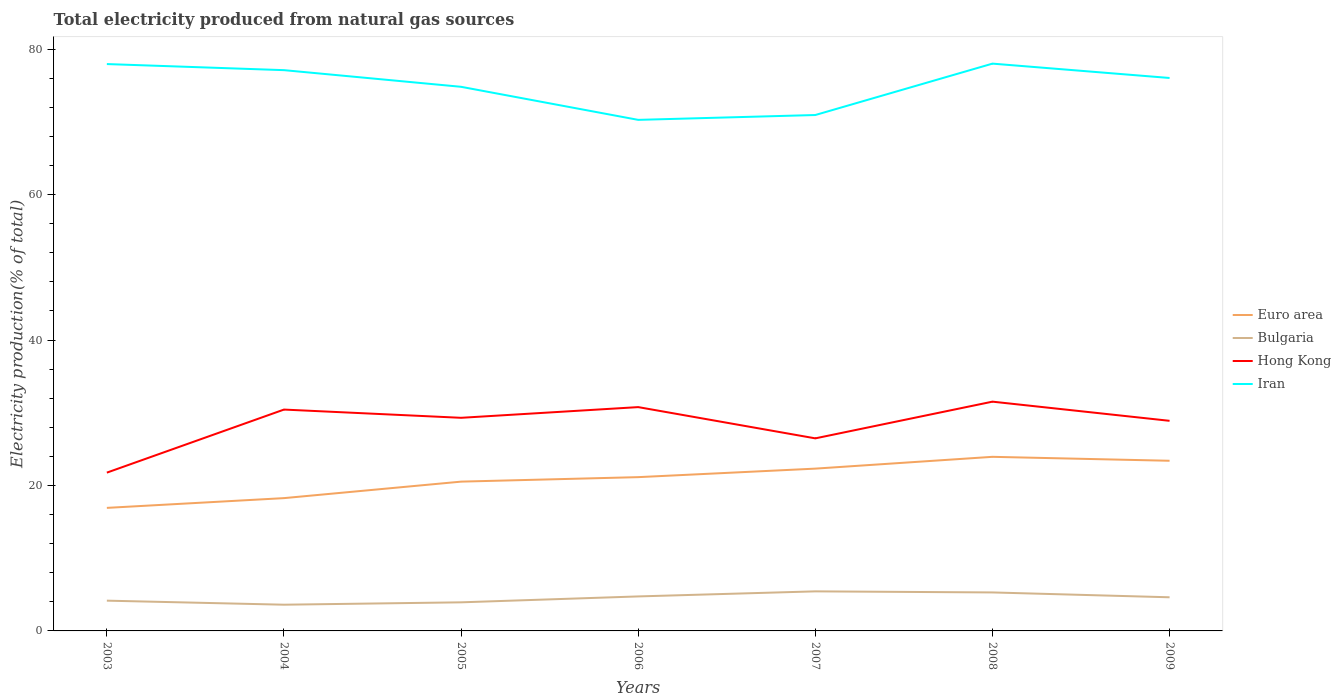Does the line corresponding to Bulgaria intersect with the line corresponding to Euro area?
Provide a succinct answer. No. Across all years, what is the maximum total electricity produced in Hong Kong?
Ensure brevity in your answer.  21.77. In which year was the total electricity produced in Iran maximum?
Your response must be concise. 2006. What is the total total electricity produced in Hong Kong in the graph?
Provide a succinct answer. 2.64. What is the difference between the highest and the second highest total electricity produced in Hong Kong?
Your answer should be very brief. 9.76. Is the total electricity produced in Bulgaria strictly greater than the total electricity produced in Hong Kong over the years?
Give a very brief answer. Yes. How many years are there in the graph?
Offer a terse response. 7. What is the difference between two consecutive major ticks on the Y-axis?
Your answer should be very brief. 20. How many legend labels are there?
Provide a succinct answer. 4. What is the title of the graph?
Your answer should be very brief. Total electricity produced from natural gas sources. What is the label or title of the X-axis?
Ensure brevity in your answer.  Years. What is the label or title of the Y-axis?
Provide a short and direct response. Electricity production(% of total). What is the Electricity production(% of total) of Euro area in 2003?
Provide a succinct answer. 16.92. What is the Electricity production(% of total) in Bulgaria in 2003?
Your answer should be compact. 4.16. What is the Electricity production(% of total) of Hong Kong in 2003?
Your response must be concise. 21.77. What is the Electricity production(% of total) in Iran in 2003?
Provide a short and direct response. 77.96. What is the Electricity production(% of total) of Euro area in 2004?
Offer a terse response. 18.26. What is the Electricity production(% of total) in Bulgaria in 2004?
Your answer should be very brief. 3.61. What is the Electricity production(% of total) of Hong Kong in 2004?
Your response must be concise. 30.44. What is the Electricity production(% of total) in Iran in 2004?
Offer a very short reply. 77.12. What is the Electricity production(% of total) of Euro area in 2005?
Ensure brevity in your answer.  20.53. What is the Electricity production(% of total) in Bulgaria in 2005?
Ensure brevity in your answer.  3.93. What is the Electricity production(% of total) in Hong Kong in 2005?
Your answer should be compact. 29.31. What is the Electricity production(% of total) of Iran in 2005?
Keep it short and to the point. 74.83. What is the Electricity production(% of total) in Euro area in 2006?
Give a very brief answer. 21.15. What is the Electricity production(% of total) of Bulgaria in 2006?
Offer a very short reply. 4.74. What is the Electricity production(% of total) of Hong Kong in 2006?
Ensure brevity in your answer.  30.78. What is the Electricity production(% of total) of Iran in 2006?
Keep it short and to the point. 70.29. What is the Electricity production(% of total) of Euro area in 2007?
Provide a succinct answer. 22.32. What is the Electricity production(% of total) of Bulgaria in 2007?
Your answer should be very brief. 5.44. What is the Electricity production(% of total) of Hong Kong in 2007?
Offer a terse response. 26.48. What is the Electricity production(% of total) in Iran in 2007?
Provide a succinct answer. 70.95. What is the Electricity production(% of total) in Euro area in 2008?
Make the answer very short. 23.94. What is the Electricity production(% of total) of Bulgaria in 2008?
Offer a very short reply. 5.29. What is the Electricity production(% of total) in Hong Kong in 2008?
Give a very brief answer. 31.53. What is the Electricity production(% of total) of Iran in 2008?
Keep it short and to the point. 78.02. What is the Electricity production(% of total) of Euro area in 2009?
Your answer should be very brief. 23.4. What is the Electricity production(% of total) of Bulgaria in 2009?
Make the answer very short. 4.63. What is the Electricity production(% of total) in Hong Kong in 2009?
Make the answer very short. 28.9. What is the Electricity production(% of total) of Iran in 2009?
Your answer should be compact. 76.05. Across all years, what is the maximum Electricity production(% of total) in Euro area?
Keep it short and to the point. 23.94. Across all years, what is the maximum Electricity production(% of total) of Bulgaria?
Give a very brief answer. 5.44. Across all years, what is the maximum Electricity production(% of total) of Hong Kong?
Keep it short and to the point. 31.53. Across all years, what is the maximum Electricity production(% of total) in Iran?
Offer a very short reply. 78.02. Across all years, what is the minimum Electricity production(% of total) of Euro area?
Give a very brief answer. 16.92. Across all years, what is the minimum Electricity production(% of total) of Bulgaria?
Your answer should be compact. 3.61. Across all years, what is the minimum Electricity production(% of total) of Hong Kong?
Your answer should be very brief. 21.77. Across all years, what is the minimum Electricity production(% of total) of Iran?
Offer a very short reply. 70.29. What is the total Electricity production(% of total) in Euro area in the graph?
Your answer should be very brief. 146.53. What is the total Electricity production(% of total) of Bulgaria in the graph?
Give a very brief answer. 31.81. What is the total Electricity production(% of total) in Hong Kong in the graph?
Your answer should be very brief. 199.21. What is the total Electricity production(% of total) in Iran in the graph?
Provide a short and direct response. 525.22. What is the difference between the Electricity production(% of total) of Euro area in 2003 and that in 2004?
Give a very brief answer. -1.34. What is the difference between the Electricity production(% of total) in Bulgaria in 2003 and that in 2004?
Make the answer very short. 0.56. What is the difference between the Electricity production(% of total) in Hong Kong in 2003 and that in 2004?
Your answer should be compact. -8.67. What is the difference between the Electricity production(% of total) of Iran in 2003 and that in 2004?
Offer a very short reply. 0.84. What is the difference between the Electricity production(% of total) in Euro area in 2003 and that in 2005?
Your answer should be very brief. -3.61. What is the difference between the Electricity production(% of total) in Bulgaria in 2003 and that in 2005?
Your answer should be compact. 0.23. What is the difference between the Electricity production(% of total) of Hong Kong in 2003 and that in 2005?
Your answer should be very brief. -7.54. What is the difference between the Electricity production(% of total) in Iran in 2003 and that in 2005?
Provide a short and direct response. 3.13. What is the difference between the Electricity production(% of total) of Euro area in 2003 and that in 2006?
Offer a terse response. -4.23. What is the difference between the Electricity production(% of total) in Bulgaria in 2003 and that in 2006?
Your response must be concise. -0.58. What is the difference between the Electricity production(% of total) in Hong Kong in 2003 and that in 2006?
Your response must be concise. -9.01. What is the difference between the Electricity production(% of total) of Iran in 2003 and that in 2006?
Provide a short and direct response. 7.67. What is the difference between the Electricity production(% of total) of Euro area in 2003 and that in 2007?
Keep it short and to the point. -5.4. What is the difference between the Electricity production(% of total) in Bulgaria in 2003 and that in 2007?
Give a very brief answer. -1.28. What is the difference between the Electricity production(% of total) of Hong Kong in 2003 and that in 2007?
Keep it short and to the point. -4.71. What is the difference between the Electricity production(% of total) in Iran in 2003 and that in 2007?
Make the answer very short. 7.01. What is the difference between the Electricity production(% of total) in Euro area in 2003 and that in 2008?
Give a very brief answer. -7.02. What is the difference between the Electricity production(% of total) in Bulgaria in 2003 and that in 2008?
Offer a very short reply. -1.13. What is the difference between the Electricity production(% of total) of Hong Kong in 2003 and that in 2008?
Make the answer very short. -9.76. What is the difference between the Electricity production(% of total) in Iran in 2003 and that in 2008?
Your answer should be very brief. -0.06. What is the difference between the Electricity production(% of total) in Euro area in 2003 and that in 2009?
Ensure brevity in your answer.  -6.48. What is the difference between the Electricity production(% of total) of Bulgaria in 2003 and that in 2009?
Provide a succinct answer. -0.46. What is the difference between the Electricity production(% of total) of Hong Kong in 2003 and that in 2009?
Offer a terse response. -7.13. What is the difference between the Electricity production(% of total) in Iran in 2003 and that in 2009?
Ensure brevity in your answer.  1.91. What is the difference between the Electricity production(% of total) of Euro area in 2004 and that in 2005?
Keep it short and to the point. -2.27. What is the difference between the Electricity production(% of total) in Bulgaria in 2004 and that in 2005?
Your response must be concise. -0.33. What is the difference between the Electricity production(% of total) of Hong Kong in 2004 and that in 2005?
Provide a short and direct response. 1.13. What is the difference between the Electricity production(% of total) in Iran in 2004 and that in 2005?
Offer a very short reply. 2.29. What is the difference between the Electricity production(% of total) in Euro area in 2004 and that in 2006?
Your answer should be very brief. -2.89. What is the difference between the Electricity production(% of total) of Bulgaria in 2004 and that in 2006?
Offer a terse response. -1.14. What is the difference between the Electricity production(% of total) of Hong Kong in 2004 and that in 2006?
Ensure brevity in your answer.  -0.34. What is the difference between the Electricity production(% of total) in Iran in 2004 and that in 2006?
Offer a very short reply. 6.84. What is the difference between the Electricity production(% of total) of Euro area in 2004 and that in 2007?
Make the answer very short. -4.06. What is the difference between the Electricity production(% of total) of Bulgaria in 2004 and that in 2007?
Ensure brevity in your answer.  -1.83. What is the difference between the Electricity production(% of total) of Hong Kong in 2004 and that in 2007?
Keep it short and to the point. 3.96. What is the difference between the Electricity production(% of total) in Iran in 2004 and that in 2007?
Offer a terse response. 6.17. What is the difference between the Electricity production(% of total) in Euro area in 2004 and that in 2008?
Keep it short and to the point. -5.68. What is the difference between the Electricity production(% of total) in Bulgaria in 2004 and that in 2008?
Keep it short and to the point. -1.69. What is the difference between the Electricity production(% of total) of Hong Kong in 2004 and that in 2008?
Provide a short and direct response. -1.09. What is the difference between the Electricity production(% of total) in Iran in 2004 and that in 2008?
Your answer should be compact. -0.9. What is the difference between the Electricity production(% of total) of Euro area in 2004 and that in 2009?
Offer a terse response. -5.14. What is the difference between the Electricity production(% of total) of Bulgaria in 2004 and that in 2009?
Your answer should be compact. -1.02. What is the difference between the Electricity production(% of total) of Hong Kong in 2004 and that in 2009?
Make the answer very short. 1.55. What is the difference between the Electricity production(% of total) in Iran in 2004 and that in 2009?
Make the answer very short. 1.08. What is the difference between the Electricity production(% of total) of Euro area in 2005 and that in 2006?
Your answer should be very brief. -0.62. What is the difference between the Electricity production(% of total) in Bulgaria in 2005 and that in 2006?
Keep it short and to the point. -0.81. What is the difference between the Electricity production(% of total) in Hong Kong in 2005 and that in 2006?
Offer a terse response. -1.47. What is the difference between the Electricity production(% of total) in Iran in 2005 and that in 2006?
Offer a terse response. 4.55. What is the difference between the Electricity production(% of total) of Euro area in 2005 and that in 2007?
Provide a short and direct response. -1.79. What is the difference between the Electricity production(% of total) of Bulgaria in 2005 and that in 2007?
Provide a short and direct response. -1.51. What is the difference between the Electricity production(% of total) in Hong Kong in 2005 and that in 2007?
Ensure brevity in your answer.  2.83. What is the difference between the Electricity production(% of total) of Iran in 2005 and that in 2007?
Keep it short and to the point. 3.88. What is the difference between the Electricity production(% of total) of Euro area in 2005 and that in 2008?
Keep it short and to the point. -3.41. What is the difference between the Electricity production(% of total) in Bulgaria in 2005 and that in 2008?
Give a very brief answer. -1.36. What is the difference between the Electricity production(% of total) in Hong Kong in 2005 and that in 2008?
Ensure brevity in your answer.  -2.22. What is the difference between the Electricity production(% of total) of Iran in 2005 and that in 2008?
Your answer should be very brief. -3.19. What is the difference between the Electricity production(% of total) in Euro area in 2005 and that in 2009?
Make the answer very short. -2.87. What is the difference between the Electricity production(% of total) in Bulgaria in 2005 and that in 2009?
Ensure brevity in your answer.  -0.69. What is the difference between the Electricity production(% of total) of Hong Kong in 2005 and that in 2009?
Make the answer very short. 0.41. What is the difference between the Electricity production(% of total) in Iran in 2005 and that in 2009?
Offer a terse response. -1.21. What is the difference between the Electricity production(% of total) in Euro area in 2006 and that in 2007?
Offer a terse response. -1.17. What is the difference between the Electricity production(% of total) in Bulgaria in 2006 and that in 2007?
Ensure brevity in your answer.  -0.7. What is the difference between the Electricity production(% of total) in Hong Kong in 2006 and that in 2007?
Ensure brevity in your answer.  4.3. What is the difference between the Electricity production(% of total) of Iran in 2006 and that in 2007?
Give a very brief answer. -0.67. What is the difference between the Electricity production(% of total) of Euro area in 2006 and that in 2008?
Keep it short and to the point. -2.79. What is the difference between the Electricity production(% of total) in Bulgaria in 2006 and that in 2008?
Keep it short and to the point. -0.55. What is the difference between the Electricity production(% of total) of Hong Kong in 2006 and that in 2008?
Your answer should be compact. -0.75. What is the difference between the Electricity production(% of total) of Iran in 2006 and that in 2008?
Your answer should be very brief. -7.73. What is the difference between the Electricity production(% of total) of Euro area in 2006 and that in 2009?
Your response must be concise. -2.25. What is the difference between the Electricity production(% of total) of Bulgaria in 2006 and that in 2009?
Offer a terse response. 0.12. What is the difference between the Electricity production(% of total) of Hong Kong in 2006 and that in 2009?
Your answer should be compact. 1.89. What is the difference between the Electricity production(% of total) of Iran in 2006 and that in 2009?
Provide a short and direct response. -5.76. What is the difference between the Electricity production(% of total) in Euro area in 2007 and that in 2008?
Give a very brief answer. -1.62. What is the difference between the Electricity production(% of total) of Bulgaria in 2007 and that in 2008?
Offer a very short reply. 0.15. What is the difference between the Electricity production(% of total) in Hong Kong in 2007 and that in 2008?
Keep it short and to the point. -5.05. What is the difference between the Electricity production(% of total) in Iran in 2007 and that in 2008?
Give a very brief answer. -7.07. What is the difference between the Electricity production(% of total) in Euro area in 2007 and that in 2009?
Offer a terse response. -1.08. What is the difference between the Electricity production(% of total) of Bulgaria in 2007 and that in 2009?
Provide a short and direct response. 0.81. What is the difference between the Electricity production(% of total) of Hong Kong in 2007 and that in 2009?
Your answer should be compact. -2.41. What is the difference between the Electricity production(% of total) of Iran in 2007 and that in 2009?
Your answer should be very brief. -5.09. What is the difference between the Electricity production(% of total) of Euro area in 2008 and that in 2009?
Your answer should be compact. 0.54. What is the difference between the Electricity production(% of total) of Bulgaria in 2008 and that in 2009?
Your answer should be compact. 0.67. What is the difference between the Electricity production(% of total) in Hong Kong in 2008 and that in 2009?
Keep it short and to the point. 2.64. What is the difference between the Electricity production(% of total) in Iran in 2008 and that in 2009?
Your answer should be compact. 1.97. What is the difference between the Electricity production(% of total) of Euro area in 2003 and the Electricity production(% of total) of Bulgaria in 2004?
Your answer should be very brief. 13.32. What is the difference between the Electricity production(% of total) in Euro area in 2003 and the Electricity production(% of total) in Hong Kong in 2004?
Keep it short and to the point. -13.52. What is the difference between the Electricity production(% of total) of Euro area in 2003 and the Electricity production(% of total) of Iran in 2004?
Ensure brevity in your answer.  -60.2. What is the difference between the Electricity production(% of total) of Bulgaria in 2003 and the Electricity production(% of total) of Hong Kong in 2004?
Keep it short and to the point. -26.28. What is the difference between the Electricity production(% of total) of Bulgaria in 2003 and the Electricity production(% of total) of Iran in 2004?
Ensure brevity in your answer.  -72.96. What is the difference between the Electricity production(% of total) in Hong Kong in 2003 and the Electricity production(% of total) in Iran in 2004?
Your response must be concise. -55.35. What is the difference between the Electricity production(% of total) of Euro area in 2003 and the Electricity production(% of total) of Bulgaria in 2005?
Offer a terse response. 12.99. What is the difference between the Electricity production(% of total) of Euro area in 2003 and the Electricity production(% of total) of Hong Kong in 2005?
Offer a very short reply. -12.39. What is the difference between the Electricity production(% of total) of Euro area in 2003 and the Electricity production(% of total) of Iran in 2005?
Give a very brief answer. -57.91. What is the difference between the Electricity production(% of total) of Bulgaria in 2003 and the Electricity production(% of total) of Hong Kong in 2005?
Ensure brevity in your answer.  -25.15. What is the difference between the Electricity production(% of total) of Bulgaria in 2003 and the Electricity production(% of total) of Iran in 2005?
Your response must be concise. -70.67. What is the difference between the Electricity production(% of total) of Hong Kong in 2003 and the Electricity production(% of total) of Iran in 2005?
Provide a short and direct response. -53.06. What is the difference between the Electricity production(% of total) of Euro area in 2003 and the Electricity production(% of total) of Bulgaria in 2006?
Ensure brevity in your answer.  12.18. What is the difference between the Electricity production(% of total) of Euro area in 2003 and the Electricity production(% of total) of Hong Kong in 2006?
Provide a succinct answer. -13.86. What is the difference between the Electricity production(% of total) in Euro area in 2003 and the Electricity production(% of total) in Iran in 2006?
Your answer should be compact. -53.36. What is the difference between the Electricity production(% of total) of Bulgaria in 2003 and the Electricity production(% of total) of Hong Kong in 2006?
Give a very brief answer. -26.62. What is the difference between the Electricity production(% of total) in Bulgaria in 2003 and the Electricity production(% of total) in Iran in 2006?
Provide a short and direct response. -66.12. What is the difference between the Electricity production(% of total) in Hong Kong in 2003 and the Electricity production(% of total) in Iran in 2006?
Make the answer very short. -48.52. What is the difference between the Electricity production(% of total) in Euro area in 2003 and the Electricity production(% of total) in Bulgaria in 2007?
Your answer should be very brief. 11.48. What is the difference between the Electricity production(% of total) in Euro area in 2003 and the Electricity production(% of total) in Hong Kong in 2007?
Your response must be concise. -9.56. What is the difference between the Electricity production(% of total) of Euro area in 2003 and the Electricity production(% of total) of Iran in 2007?
Ensure brevity in your answer.  -54.03. What is the difference between the Electricity production(% of total) in Bulgaria in 2003 and the Electricity production(% of total) in Hong Kong in 2007?
Offer a terse response. -22.32. What is the difference between the Electricity production(% of total) in Bulgaria in 2003 and the Electricity production(% of total) in Iran in 2007?
Make the answer very short. -66.79. What is the difference between the Electricity production(% of total) in Hong Kong in 2003 and the Electricity production(% of total) in Iran in 2007?
Make the answer very short. -49.18. What is the difference between the Electricity production(% of total) of Euro area in 2003 and the Electricity production(% of total) of Bulgaria in 2008?
Provide a succinct answer. 11.63. What is the difference between the Electricity production(% of total) of Euro area in 2003 and the Electricity production(% of total) of Hong Kong in 2008?
Provide a short and direct response. -14.61. What is the difference between the Electricity production(% of total) of Euro area in 2003 and the Electricity production(% of total) of Iran in 2008?
Provide a succinct answer. -61.1. What is the difference between the Electricity production(% of total) in Bulgaria in 2003 and the Electricity production(% of total) in Hong Kong in 2008?
Offer a very short reply. -27.37. What is the difference between the Electricity production(% of total) of Bulgaria in 2003 and the Electricity production(% of total) of Iran in 2008?
Give a very brief answer. -73.86. What is the difference between the Electricity production(% of total) of Hong Kong in 2003 and the Electricity production(% of total) of Iran in 2008?
Keep it short and to the point. -56.25. What is the difference between the Electricity production(% of total) in Euro area in 2003 and the Electricity production(% of total) in Bulgaria in 2009?
Your answer should be compact. 12.3. What is the difference between the Electricity production(% of total) of Euro area in 2003 and the Electricity production(% of total) of Hong Kong in 2009?
Provide a succinct answer. -11.97. What is the difference between the Electricity production(% of total) in Euro area in 2003 and the Electricity production(% of total) in Iran in 2009?
Offer a terse response. -59.12. What is the difference between the Electricity production(% of total) in Bulgaria in 2003 and the Electricity production(% of total) in Hong Kong in 2009?
Give a very brief answer. -24.73. What is the difference between the Electricity production(% of total) in Bulgaria in 2003 and the Electricity production(% of total) in Iran in 2009?
Make the answer very short. -71.88. What is the difference between the Electricity production(% of total) of Hong Kong in 2003 and the Electricity production(% of total) of Iran in 2009?
Offer a terse response. -54.28. What is the difference between the Electricity production(% of total) of Euro area in 2004 and the Electricity production(% of total) of Bulgaria in 2005?
Give a very brief answer. 14.33. What is the difference between the Electricity production(% of total) in Euro area in 2004 and the Electricity production(% of total) in Hong Kong in 2005?
Your answer should be very brief. -11.05. What is the difference between the Electricity production(% of total) of Euro area in 2004 and the Electricity production(% of total) of Iran in 2005?
Your response must be concise. -56.57. What is the difference between the Electricity production(% of total) in Bulgaria in 2004 and the Electricity production(% of total) in Hong Kong in 2005?
Your answer should be compact. -25.7. What is the difference between the Electricity production(% of total) of Bulgaria in 2004 and the Electricity production(% of total) of Iran in 2005?
Give a very brief answer. -71.23. What is the difference between the Electricity production(% of total) of Hong Kong in 2004 and the Electricity production(% of total) of Iran in 2005?
Provide a succinct answer. -44.39. What is the difference between the Electricity production(% of total) of Euro area in 2004 and the Electricity production(% of total) of Bulgaria in 2006?
Provide a short and direct response. 13.52. What is the difference between the Electricity production(% of total) in Euro area in 2004 and the Electricity production(% of total) in Hong Kong in 2006?
Your answer should be compact. -12.52. What is the difference between the Electricity production(% of total) in Euro area in 2004 and the Electricity production(% of total) in Iran in 2006?
Give a very brief answer. -52.02. What is the difference between the Electricity production(% of total) in Bulgaria in 2004 and the Electricity production(% of total) in Hong Kong in 2006?
Your answer should be very brief. -27.18. What is the difference between the Electricity production(% of total) of Bulgaria in 2004 and the Electricity production(% of total) of Iran in 2006?
Your answer should be compact. -66.68. What is the difference between the Electricity production(% of total) of Hong Kong in 2004 and the Electricity production(% of total) of Iran in 2006?
Provide a short and direct response. -39.84. What is the difference between the Electricity production(% of total) in Euro area in 2004 and the Electricity production(% of total) in Bulgaria in 2007?
Offer a very short reply. 12.82. What is the difference between the Electricity production(% of total) in Euro area in 2004 and the Electricity production(% of total) in Hong Kong in 2007?
Offer a terse response. -8.22. What is the difference between the Electricity production(% of total) of Euro area in 2004 and the Electricity production(% of total) of Iran in 2007?
Your response must be concise. -52.69. What is the difference between the Electricity production(% of total) in Bulgaria in 2004 and the Electricity production(% of total) in Hong Kong in 2007?
Offer a very short reply. -22.88. What is the difference between the Electricity production(% of total) of Bulgaria in 2004 and the Electricity production(% of total) of Iran in 2007?
Offer a terse response. -67.35. What is the difference between the Electricity production(% of total) of Hong Kong in 2004 and the Electricity production(% of total) of Iran in 2007?
Keep it short and to the point. -40.51. What is the difference between the Electricity production(% of total) in Euro area in 2004 and the Electricity production(% of total) in Bulgaria in 2008?
Provide a short and direct response. 12.97. What is the difference between the Electricity production(% of total) of Euro area in 2004 and the Electricity production(% of total) of Hong Kong in 2008?
Ensure brevity in your answer.  -13.27. What is the difference between the Electricity production(% of total) in Euro area in 2004 and the Electricity production(% of total) in Iran in 2008?
Provide a succinct answer. -59.76. What is the difference between the Electricity production(% of total) of Bulgaria in 2004 and the Electricity production(% of total) of Hong Kong in 2008?
Offer a terse response. -27.92. What is the difference between the Electricity production(% of total) of Bulgaria in 2004 and the Electricity production(% of total) of Iran in 2008?
Offer a very short reply. -74.41. What is the difference between the Electricity production(% of total) of Hong Kong in 2004 and the Electricity production(% of total) of Iran in 2008?
Offer a very short reply. -47.58. What is the difference between the Electricity production(% of total) in Euro area in 2004 and the Electricity production(% of total) in Bulgaria in 2009?
Provide a short and direct response. 13.64. What is the difference between the Electricity production(% of total) in Euro area in 2004 and the Electricity production(% of total) in Hong Kong in 2009?
Offer a very short reply. -10.63. What is the difference between the Electricity production(% of total) of Euro area in 2004 and the Electricity production(% of total) of Iran in 2009?
Your answer should be compact. -57.78. What is the difference between the Electricity production(% of total) in Bulgaria in 2004 and the Electricity production(% of total) in Hong Kong in 2009?
Ensure brevity in your answer.  -25.29. What is the difference between the Electricity production(% of total) of Bulgaria in 2004 and the Electricity production(% of total) of Iran in 2009?
Your answer should be compact. -72.44. What is the difference between the Electricity production(% of total) of Hong Kong in 2004 and the Electricity production(% of total) of Iran in 2009?
Ensure brevity in your answer.  -45.6. What is the difference between the Electricity production(% of total) in Euro area in 2005 and the Electricity production(% of total) in Bulgaria in 2006?
Give a very brief answer. 15.79. What is the difference between the Electricity production(% of total) in Euro area in 2005 and the Electricity production(% of total) in Hong Kong in 2006?
Your response must be concise. -10.25. What is the difference between the Electricity production(% of total) in Euro area in 2005 and the Electricity production(% of total) in Iran in 2006?
Your answer should be very brief. -49.75. What is the difference between the Electricity production(% of total) in Bulgaria in 2005 and the Electricity production(% of total) in Hong Kong in 2006?
Offer a terse response. -26.85. What is the difference between the Electricity production(% of total) in Bulgaria in 2005 and the Electricity production(% of total) in Iran in 2006?
Provide a succinct answer. -66.35. What is the difference between the Electricity production(% of total) in Hong Kong in 2005 and the Electricity production(% of total) in Iran in 2006?
Your answer should be very brief. -40.98. What is the difference between the Electricity production(% of total) of Euro area in 2005 and the Electricity production(% of total) of Bulgaria in 2007?
Provide a short and direct response. 15.09. What is the difference between the Electricity production(% of total) of Euro area in 2005 and the Electricity production(% of total) of Hong Kong in 2007?
Provide a succinct answer. -5.95. What is the difference between the Electricity production(% of total) in Euro area in 2005 and the Electricity production(% of total) in Iran in 2007?
Keep it short and to the point. -50.42. What is the difference between the Electricity production(% of total) in Bulgaria in 2005 and the Electricity production(% of total) in Hong Kong in 2007?
Offer a terse response. -22.55. What is the difference between the Electricity production(% of total) of Bulgaria in 2005 and the Electricity production(% of total) of Iran in 2007?
Ensure brevity in your answer.  -67.02. What is the difference between the Electricity production(% of total) in Hong Kong in 2005 and the Electricity production(% of total) in Iran in 2007?
Make the answer very short. -41.64. What is the difference between the Electricity production(% of total) in Euro area in 2005 and the Electricity production(% of total) in Bulgaria in 2008?
Provide a short and direct response. 15.24. What is the difference between the Electricity production(% of total) in Euro area in 2005 and the Electricity production(% of total) in Hong Kong in 2008?
Provide a short and direct response. -11. What is the difference between the Electricity production(% of total) in Euro area in 2005 and the Electricity production(% of total) in Iran in 2008?
Make the answer very short. -57.49. What is the difference between the Electricity production(% of total) in Bulgaria in 2005 and the Electricity production(% of total) in Hong Kong in 2008?
Provide a succinct answer. -27.6. What is the difference between the Electricity production(% of total) in Bulgaria in 2005 and the Electricity production(% of total) in Iran in 2008?
Your answer should be very brief. -74.09. What is the difference between the Electricity production(% of total) of Hong Kong in 2005 and the Electricity production(% of total) of Iran in 2008?
Provide a short and direct response. -48.71. What is the difference between the Electricity production(% of total) in Euro area in 2005 and the Electricity production(% of total) in Bulgaria in 2009?
Offer a very short reply. 15.91. What is the difference between the Electricity production(% of total) in Euro area in 2005 and the Electricity production(% of total) in Hong Kong in 2009?
Your answer should be very brief. -8.36. What is the difference between the Electricity production(% of total) in Euro area in 2005 and the Electricity production(% of total) in Iran in 2009?
Provide a succinct answer. -55.51. What is the difference between the Electricity production(% of total) of Bulgaria in 2005 and the Electricity production(% of total) of Hong Kong in 2009?
Your response must be concise. -24.96. What is the difference between the Electricity production(% of total) in Bulgaria in 2005 and the Electricity production(% of total) in Iran in 2009?
Provide a short and direct response. -72.11. What is the difference between the Electricity production(% of total) of Hong Kong in 2005 and the Electricity production(% of total) of Iran in 2009?
Offer a very short reply. -46.74. What is the difference between the Electricity production(% of total) in Euro area in 2006 and the Electricity production(% of total) in Bulgaria in 2007?
Your answer should be very brief. 15.71. What is the difference between the Electricity production(% of total) of Euro area in 2006 and the Electricity production(% of total) of Hong Kong in 2007?
Keep it short and to the point. -5.33. What is the difference between the Electricity production(% of total) of Euro area in 2006 and the Electricity production(% of total) of Iran in 2007?
Your answer should be compact. -49.8. What is the difference between the Electricity production(% of total) in Bulgaria in 2006 and the Electricity production(% of total) in Hong Kong in 2007?
Provide a succinct answer. -21.74. What is the difference between the Electricity production(% of total) of Bulgaria in 2006 and the Electricity production(% of total) of Iran in 2007?
Provide a short and direct response. -66.21. What is the difference between the Electricity production(% of total) of Hong Kong in 2006 and the Electricity production(% of total) of Iran in 2007?
Make the answer very short. -40.17. What is the difference between the Electricity production(% of total) in Euro area in 2006 and the Electricity production(% of total) in Bulgaria in 2008?
Give a very brief answer. 15.86. What is the difference between the Electricity production(% of total) in Euro area in 2006 and the Electricity production(% of total) in Hong Kong in 2008?
Provide a short and direct response. -10.38. What is the difference between the Electricity production(% of total) in Euro area in 2006 and the Electricity production(% of total) in Iran in 2008?
Keep it short and to the point. -56.87. What is the difference between the Electricity production(% of total) of Bulgaria in 2006 and the Electricity production(% of total) of Hong Kong in 2008?
Your answer should be compact. -26.79. What is the difference between the Electricity production(% of total) in Bulgaria in 2006 and the Electricity production(% of total) in Iran in 2008?
Give a very brief answer. -73.28. What is the difference between the Electricity production(% of total) of Hong Kong in 2006 and the Electricity production(% of total) of Iran in 2008?
Your answer should be compact. -47.24. What is the difference between the Electricity production(% of total) in Euro area in 2006 and the Electricity production(% of total) in Bulgaria in 2009?
Keep it short and to the point. 16.52. What is the difference between the Electricity production(% of total) in Euro area in 2006 and the Electricity production(% of total) in Hong Kong in 2009?
Give a very brief answer. -7.75. What is the difference between the Electricity production(% of total) of Euro area in 2006 and the Electricity production(% of total) of Iran in 2009?
Keep it short and to the point. -54.9. What is the difference between the Electricity production(% of total) of Bulgaria in 2006 and the Electricity production(% of total) of Hong Kong in 2009?
Ensure brevity in your answer.  -24.15. What is the difference between the Electricity production(% of total) in Bulgaria in 2006 and the Electricity production(% of total) in Iran in 2009?
Your answer should be very brief. -71.3. What is the difference between the Electricity production(% of total) in Hong Kong in 2006 and the Electricity production(% of total) in Iran in 2009?
Ensure brevity in your answer.  -45.26. What is the difference between the Electricity production(% of total) of Euro area in 2007 and the Electricity production(% of total) of Bulgaria in 2008?
Give a very brief answer. 17.03. What is the difference between the Electricity production(% of total) in Euro area in 2007 and the Electricity production(% of total) in Hong Kong in 2008?
Offer a terse response. -9.21. What is the difference between the Electricity production(% of total) of Euro area in 2007 and the Electricity production(% of total) of Iran in 2008?
Keep it short and to the point. -55.7. What is the difference between the Electricity production(% of total) of Bulgaria in 2007 and the Electricity production(% of total) of Hong Kong in 2008?
Give a very brief answer. -26.09. What is the difference between the Electricity production(% of total) in Bulgaria in 2007 and the Electricity production(% of total) in Iran in 2008?
Make the answer very short. -72.58. What is the difference between the Electricity production(% of total) in Hong Kong in 2007 and the Electricity production(% of total) in Iran in 2008?
Provide a succinct answer. -51.54. What is the difference between the Electricity production(% of total) in Euro area in 2007 and the Electricity production(% of total) in Bulgaria in 2009?
Your answer should be compact. 17.69. What is the difference between the Electricity production(% of total) in Euro area in 2007 and the Electricity production(% of total) in Hong Kong in 2009?
Ensure brevity in your answer.  -6.58. What is the difference between the Electricity production(% of total) of Euro area in 2007 and the Electricity production(% of total) of Iran in 2009?
Your answer should be compact. -53.73. What is the difference between the Electricity production(% of total) of Bulgaria in 2007 and the Electricity production(% of total) of Hong Kong in 2009?
Ensure brevity in your answer.  -23.46. What is the difference between the Electricity production(% of total) in Bulgaria in 2007 and the Electricity production(% of total) in Iran in 2009?
Ensure brevity in your answer.  -70.61. What is the difference between the Electricity production(% of total) of Hong Kong in 2007 and the Electricity production(% of total) of Iran in 2009?
Your response must be concise. -49.56. What is the difference between the Electricity production(% of total) in Euro area in 2008 and the Electricity production(% of total) in Bulgaria in 2009?
Your answer should be very brief. 19.32. What is the difference between the Electricity production(% of total) in Euro area in 2008 and the Electricity production(% of total) in Hong Kong in 2009?
Ensure brevity in your answer.  -4.95. What is the difference between the Electricity production(% of total) of Euro area in 2008 and the Electricity production(% of total) of Iran in 2009?
Keep it short and to the point. -52.1. What is the difference between the Electricity production(% of total) of Bulgaria in 2008 and the Electricity production(% of total) of Hong Kong in 2009?
Offer a very short reply. -23.6. What is the difference between the Electricity production(% of total) in Bulgaria in 2008 and the Electricity production(% of total) in Iran in 2009?
Give a very brief answer. -70.75. What is the difference between the Electricity production(% of total) of Hong Kong in 2008 and the Electricity production(% of total) of Iran in 2009?
Your response must be concise. -44.51. What is the average Electricity production(% of total) in Euro area per year?
Your response must be concise. 20.93. What is the average Electricity production(% of total) in Bulgaria per year?
Provide a succinct answer. 4.54. What is the average Electricity production(% of total) of Hong Kong per year?
Your answer should be compact. 28.46. What is the average Electricity production(% of total) in Iran per year?
Your answer should be very brief. 75.03. In the year 2003, what is the difference between the Electricity production(% of total) of Euro area and Electricity production(% of total) of Bulgaria?
Ensure brevity in your answer.  12.76. In the year 2003, what is the difference between the Electricity production(% of total) of Euro area and Electricity production(% of total) of Hong Kong?
Keep it short and to the point. -4.85. In the year 2003, what is the difference between the Electricity production(% of total) in Euro area and Electricity production(% of total) in Iran?
Give a very brief answer. -61.04. In the year 2003, what is the difference between the Electricity production(% of total) of Bulgaria and Electricity production(% of total) of Hong Kong?
Make the answer very short. -17.61. In the year 2003, what is the difference between the Electricity production(% of total) of Bulgaria and Electricity production(% of total) of Iran?
Make the answer very short. -73.8. In the year 2003, what is the difference between the Electricity production(% of total) of Hong Kong and Electricity production(% of total) of Iran?
Your answer should be compact. -56.19. In the year 2004, what is the difference between the Electricity production(% of total) in Euro area and Electricity production(% of total) in Bulgaria?
Your answer should be compact. 14.66. In the year 2004, what is the difference between the Electricity production(% of total) in Euro area and Electricity production(% of total) in Hong Kong?
Give a very brief answer. -12.18. In the year 2004, what is the difference between the Electricity production(% of total) in Euro area and Electricity production(% of total) in Iran?
Offer a very short reply. -58.86. In the year 2004, what is the difference between the Electricity production(% of total) in Bulgaria and Electricity production(% of total) in Hong Kong?
Offer a very short reply. -26.84. In the year 2004, what is the difference between the Electricity production(% of total) of Bulgaria and Electricity production(% of total) of Iran?
Your answer should be compact. -73.52. In the year 2004, what is the difference between the Electricity production(% of total) in Hong Kong and Electricity production(% of total) in Iran?
Your answer should be very brief. -46.68. In the year 2005, what is the difference between the Electricity production(% of total) in Euro area and Electricity production(% of total) in Bulgaria?
Offer a terse response. 16.6. In the year 2005, what is the difference between the Electricity production(% of total) in Euro area and Electricity production(% of total) in Hong Kong?
Your answer should be compact. -8.78. In the year 2005, what is the difference between the Electricity production(% of total) of Euro area and Electricity production(% of total) of Iran?
Offer a very short reply. -54.3. In the year 2005, what is the difference between the Electricity production(% of total) of Bulgaria and Electricity production(% of total) of Hong Kong?
Give a very brief answer. -25.38. In the year 2005, what is the difference between the Electricity production(% of total) of Bulgaria and Electricity production(% of total) of Iran?
Provide a succinct answer. -70.9. In the year 2005, what is the difference between the Electricity production(% of total) of Hong Kong and Electricity production(% of total) of Iran?
Offer a terse response. -45.52. In the year 2006, what is the difference between the Electricity production(% of total) in Euro area and Electricity production(% of total) in Bulgaria?
Ensure brevity in your answer.  16.4. In the year 2006, what is the difference between the Electricity production(% of total) of Euro area and Electricity production(% of total) of Hong Kong?
Ensure brevity in your answer.  -9.63. In the year 2006, what is the difference between the Electricity production(% of total) of Euro area and Electricity production(% of total) of Iran?
Make the answer very short. -49.14. In the year 2006, what is the difference between the Electricity production(% of total) in Bulgaria and Electricity production(% of total) in Hong Kong?
Your answer should be very brief. -26.04. In the year 2006, what is the difference between the Electricity production(% of total) in Bulgaria and Electricity production(% of total) in Iran?
Your response must be concise. -65.54. In the year 2006, what is the difference between the Electricity production(% of total) of Hong Kong and Electricity production(% of total) of Iran?
Offer a very short reply. -39.5. In the year 2007, what is the difference between the Electricity production(% of total) in Euro area and Electricity production(% of total) in Bulgaria?
Keep it short and to the point. 16.88. In the year 2007, what is the difference between the Electricity production(% of total) in Euro area and Electricity production(% of total) in Hong Kong?
Give a very brief answer. -4.16. In the year 2007, what is the difference between the Electricity production(% of total) of Euro area and Electricity production(% of total) of Iran?
Your answer should be very brief. -48.63. In the year 2007, what is the difference between the Electricity production(% of total) in Bulgaria and Electricity production(% of total) in Hong Kong?
Provide a succinct answer. -21.04. In the year 2007, what is the difference between the Electricity production(% of total) of Bulgaria and Electricity production(% of total) of Iran?
Provide a short and direct response. -65.51. In the year 2007, what is the difference between the Electricity production(% of total) of Hong Kong and Electricity production(% of total) of Iran?
Offer a terse response. -44.47. In the year 2008, what is the difference between the Electricity production(% of total) in Euro area and Electricity production(% of total) in Bulgaria?
Offer a terse response. 18.65. In the year 2008, what is the difference between the Electricity production(% of total) of Euro area and Electricity production(% of total) of Hong Kong?
Your answer should be compact. -7.59. In the year 2008, what is the difference between the Electricity production(% of total) in Euro area and Electricity production(% of total) in Iran?
Your answer should be very brief. -54.08. In the year 2008, what is the difference between the Electricity production(% of total) of Bulgaria and Electricity production(% of total) of Hong Kong?
Give a very brief answer. -26.24. In the year 2008, what is the difference between the Electricity production(% of total) of Bulgaria and Electricity production(% of total) of Iran?
Your response must be concise. -72.73. In the year 2008, what is the difference between the Electricity production(% of total) of Hong Kong and Electricity production(% of total) of Iran?
Provide a short and direct response. -46.49. In the year 2009, what is the difference between the Electricity production(% of total) in Euro area and Electricity production(% of total) in Bulgaria?
Make the answer very short. 18.78. In the year 2009, what is the difference between the Electricity production(% of total) in Euro area and Electricity production(% of total) in Hong Kong?
Ensure brevity in your answer.  -5.49. In the year 2009, what is the difference between the Electricity production(% of total) in Euro area and Electricity production(% of total) in Iran?
Your answer should be very brief. -52.64. In the year 2009, what is the difference between the Electricity production(% of total) of Bulgaria and Electricity production(% of total) of Hong Kong?
Your answer should be very brief. -24.27. In the year 2009, what is the difference between the Electricity production(% of total) in Bulgaria and Electricity production(% of total) in Iran?
Provide a short and direct response. -71.42. In the year 2009, what is the difference between the Electricity production(% of total) of Hong Kong and Electricity production(% of total) of Iran?
Ensure brevity in your answer.  -47.15. What is the ratio of the Electricity production(% of total) of Euro area in 2003 to that in 2004?
Ensure brevity in your answer.  0.93. What is the ratio of the Electricity production(% of total) of Bulgaria in 2003 to that in 2004?
Provide a succinct answer. 1.15. What is the ratio of the Electricity production(% of total) in Hong Kong in 2003 to that in 2004?
Provide a short and direct response. 0.72. What is the ratio of the Electricity production(% of total) in Iran in 2003 to that in 2004?
Provide a short and direct response. 1.01. What is the ratio of the Electricity production(% of total) in Euro area in 2003 to that in 2005?
Offer a very short reply. 0.82. What is the ratio of the Electricity production(% of total) of Bulgaria in 2003 to that in 2005?
Provide a short and direct response. 1.06. What is the ratio of the Electricity production(% of total) of Hong Kong in 2003 to that in 2005?
Make the answer very short. 0.74. What is the ratio of the Electricity production(% of total) in Iran in 2003 to that in 2005?
Your answer should be very brief. 1.04. What is the ratio of the Electricity production(% of total) in Euro area in 2003 to that in 2006?
Give a very brief answer. 0.8. What is the ratio of the Electricity production(% of total) in Bulgaria in 2003 to that in 2006?
Offer a terse response. 0.88. What is the ratio of the Electricity production(% of total) in Hong Kong in 2003 to that in 2006?
Ensure brevity in your answer.  0.71. What is the ratio of the Electricity production(% of total) of Iran in 2003 to that in 2006?
Offer a terse response. 1.11. What is the ratio of the Electricity production(% of total) in Euro area in 2003 to that in 2007?
Give a very brief answer. 0.76. What is the ratio of the Electricity production(% of total) of Bulgaria in 2003 to that in 2007?
Your answer should be very brief. 0.77. What is the ratio of the Electricity production(% of total) of Hong Kong in 2003 to that in 2007?
Ensure brevity in your answer.  0.82. What is the ratio of the Electricity production(% of total) in Iran in 2003 to that in 2007?
Offer a terse response. 1.1. What is the ratio of the Electricity production(% of total) of Euro area in 2003 to that in 2008?
Offer a very short reply. 0.71. What is the ratio of the Electricity production(% of total) of Bulgaria in 2003 to that in 2008?
Offer a terse response. 0.79. What is the ratio of the Electricity production(% of total) of Hong Kong in 2003 to that in 2008?
Provide a succinct answer. 0.69. What is the ratio of the Electricity production(% of total) of Euro area in 2003 to that in 2009?
Your answer should be compact. 0.72. What is the ratio of the Electricity production(% of total) in Bulgaria in 2003 to that in 2009?
Give a very brief answer. 0.9. What is the ratio of the Electricity production(% of total) of Hong Kong in 2003 to that in 2009?
Your response must be concise. 0.75. What is the ratio of the Electricity production(% of total) in Iran in 2003 to that in 2009?
Your response must be concise. 1.03. What is the ratio of the Electricity production(% of total) of Euro area in 2004 to that in 2005?
Provide a short and direct response. 0.89. What is the ratio of the Electricity production(% of total) of Bulgaria in 2004 to that in 2005?
Provide a succinct answer. 0.92. What is the ratio of the Electricity production(% of total) in Hong Kong in 2004 to that in 2005?
Make the answer very short. 1.04. What is the ratio of the Electricity production(% of total) of Iran in 2004 to that in 2005?
Ensure brevity in your answer.  1.03. What is the ratio of the Electricity production(% of total) in Euro area in 2004 to that in 2006?
Your answer should be very brief. 0.86. What is the ratio of the Electricity production(% of total) in Bulgaria in 2004 to that in 2006?
Offer a terse response. 0.76. What is the ratio of the Electricity production(% of total) in Iran in 2004 to that in 2006?
Make the answer very short. 1.1. What is the ratio of the Electricity production(% of total) of Euro area in 2004 to that in 2007?
Keep it short and to the point. 0.82. What is the ratio of the Electricity production(% of total) in Bulgaria in 2004 to that in 2007?
Make the answer very short. 0.66. What is the ratio of the Electricity production(% of total) in Hong Kong in 2004 to that in 2007?
Offer a terse response. 1.15. What is the ratio of the Electricity production(% of total) in Iran in 2004 to that in 2007?
Offer a very short reply. 1.09. What is the ratio of the Electricity production(% of total) in Euro area in 2004 to that in 2008?
Your response must be concise. 0.76. What is the ratio of the Electricity production(% of total) of Bulgaria in 2004 to that in 2008?
Give a very brief answer. 0.68. What is the ratio of the Electricity production(% of total) of Hong Kong in 2004 to that in 2008?
Your response must be concise. 0.97. What is the ratio of the Electricity production(% of total) of Euro area in 2004 to that in 2009?
Provide a succinct answer. 0.78. What is the ratio of the Electricity production(% of total) in Bulgaria in 2004 to that in 2009?
Offer a terse response. 0.78. What is the ratio of the Electricity production(% of total) in Hong Kong in 2004 to that in 2009?
Ensure brevity in your answer.  1.05. What is the ratio of the Electricity production(% of total) of Iran in 2004 to that in 2009?
Provide a short and direct response. 1.01. What is the ratio of the Electricity production(% of total) of Euro area in 2005 to that in 2006?
Offer a terse response. 0.97. What is the ratio of the Electricity production(% of total) in Bulgaria in 2005 to that in 2006?
Provide a succinct answer. 0.83. What is the ratio of the Electricity production(% of total) of Hong Kong in 2005 to that in 2006?
Your response must be concise. 0.95. What is the ratio of the Electricity production(% of total) of Iran in 2005 to that in 2006?
Keep it short and to the point. 1.06. What is the ratio of the Electricity production(% of total) of Euro area in 2005 to that in 2007?
Provide a short and direct response. 0.92. What is the ratio of the Electricity production(% of total) of Bulgaria in 2005 to that in 2007?
Give a very brief answer. 0.72. What is the ratio of the Electricity production(% of total) in Hong Kong in 2005 to that in 2007?
Your response must be concise. 1.11. What is the ratio of the Electricity production(% of total) of Iran in 2005 to that in 2007?
Give a very brief answer. 1.05. What is the ratio of the Electricity production(% of total) in Euro area in 2005 to that in 2008?
Give a very brief answer. 0.86. What is the ratio of the Electricity production(% of total) in Bulgaria in 2005 to that in 2008?
Offer a terse response. 0.74. What is the ratio of the Electricity production(% of total) in Hong Kong in 2005 to that in 2008?
Your response must be concise. 0.93. What is the ratio of the Electricity production(% of total) of Iran in 2005 to that in 2008?
Your response must be concise. 0.96. What is the ratio of the Electricity production(% of total) in Euro area in 2005 to that in 2009?
Give a very brief answer. 0.88. What is the ratio of the Electricity production(% of total) in Bulgaria in 2005 to that in 2009?
Give a very brief answer. 0.85. What is the ratio of the Electricity production(% of total) in Hong Kong in 2005 to that in 2009?
Your response must be concise. 1.01. What is the ratio of the Electricity production(% of total) in Iran in 2005 to that in 2009?
Ensure brevity in your answer.  0.98. What is the ratio of the Electricity production(% of total) in Euro area in 2006 to that in 2007?
Offer a terse response. 0.95. What is the ratio of the Electricity production(% of total) of Bulgaria in 2006 to that in 2007?
Offer a terse response. 0.87. What is the ratio of the Electricity production(% of total) in Hong Kong in 2006 to that in 2007?
Make the answer very short. 1.16. What is the ratio of the Electricity production(% of total) in Iran in 2006 to that in 2007?
Your answer should be very brief. 0.99. What is the ratio of the Electricity production(% of total) of Euro area in 2006 to that in 2008?
Make the answer very short. 0.88. What is the ratio of the Electricity production(% of total) of Bulgaria in 2006 to that in 2008?
Ensure brevity in your answer.  0.9. What is the ratio of the Electricity production(% of total) in Hong Kong in 2006 to that in 2008?
Your response must be concise. 0.98. What is the ratio of the Electricity production(% of total) in Iran in 2006 to that in 2008?
Your answer should be very brief. 0.9. What is the ratio of the Electricity production(% of total) of Euro area in 2006 to that in 2009?
Offer a terse response. 0.9. What is the ratio of the Electricity production(% of total) of Bulgaria in 2006 to that in 2009?
Your answer should be compact. 1.03. What is the ratio of the Electricity production(% of total) in Hong Kong in 2006 to that in 2009?
Make the answer very short. 1.07. What is the ratio of the Electricity production(% of total) in Iran in 2006 to that in 2009?
Ensure brevity in your answer.  0.92. What is the ratio of the Electricity production(% of total) in Euro area in 2007 to that in 2008?
Ensure brevity in your answer.  0.93. What is the ratio of the Electricity production(% of total) of Bulgaria in 2007 to that in 2008?
Your answer should be very brief. 1.03. What is the ratio of the Electricity production(% of total) in Hong Kong in 2007 to that in 2008?
Your answer should be very brief. 0.84. What is the ratio of the Electricity production(% of total) of Iran in 2007 to that in 2008?
Provide a short and direct response. 0.91. What is the ratio of the Electricity production(% of total) in Euro area in 2007 to that in 2009?
Make the answer very short. 0.95. What is the ratio of the Electricity production(% of total) of Bulgaria in 2007 to that in 2009?
Provide a succinct answer. 1.18. What is the ratio of the Electricity production(% of total) in Hong Kong in 2007 to that in 2009?
Your response must be concise. 0.92. What is the ratio of the Electricity production(% of total) in Iran in 2007 to that in 2009?
Ensure brevity in your answer.  0.93. What is the ratio of the Electricity production(% of total) of Euro area in 2008 to that in 2009?
Make the answer very short. 1.02. What is the ratio of the Electricity production(% of total) in Bulgaria in 2008 to that in 2009?
Give a very brief answer. 1.14. What is the ratio of the Electricity production(% of total) in Hong Kong in 2008 to that in 2009?
Provide a short and direct response. 1.09. What is the difference between the highest and the second highest Electricity production(% of total) of Euro area?
Your answer should be very brief. 0.54. What is the difference between the highest and the second highest Electricity production(% of total) in Bulgaria?
Provide a short and direct response. 0.15. What is the difference between the highest and the second highest Electricity production(% of total) in Hong Kong?
Your response must be concise. 0.75. What is the difference between the highest and the second highest Electricity production(% of total) in Iran?
Make the answer very short. 0.06. What is the difference between the highest and the lowest Electricity production(% of total) of Euro area?
Give a very brief answer. 7.02. What is the difference between the highest and the lowest Electricity production(% of total) in Bulgaria?
Your answer should be very brief. 1.83. What is the difference between the highest and the lowest Electricity production(% of total) in Hong Kong?
Your response must be concise. 9.76. What is the difference between the highest and the lowest Electricity production(% of total) of Iran?
Your response must be concise. 7.73. 